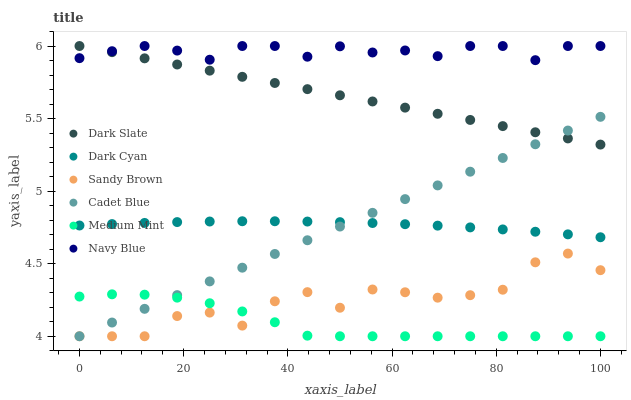Does Medium Mint have the minimum area under the curve?
Answer yes or no. Yes. Does Navy Blue have the maximum area under the curve?
Answer yes or no. Yes. Does Cadet Blue have the minimum area under the curve?
Answer yes or no. No. Does Cadet Blue have the maximum area under the curve?
Answer yes or no. No. Is Cadet Blue the smoothest?
Answer yes or no. Yes. Is Sandy Brown the roughest?
Answer yes or no. Yes. Is Navy Blue the smoothest?
Answer yes or no. No. Is Navy Blue the roughest?
Answer yes or no. No. Does Medium Mint have the lowest value?
Answer yes or no. Yes. Does Navy Blue have the lowest value?
Answer yes or no. No. Does Dark Slate have the highest value?
Answer yes or no. Yes. Does Cadet Blue have the highest value?
Answer yes or no. No. Is Medium Mint less than Dark Cyan?
Answer yes or no. Yes. Is Dark Slate greater than Dark Cyan?
Answer yes or no. Yes. Does Medium Mint intersect Cadet Blue?
Answer yes or no. Yes. Is Medium Mint less than Cadet Blue?
Answer yes or no. No. Is Medium Mint greater than Cadet Blue?
Answer yes or no. No. Does Medium Mint intersect Dark Cyan?
Answer yes or no. No. 